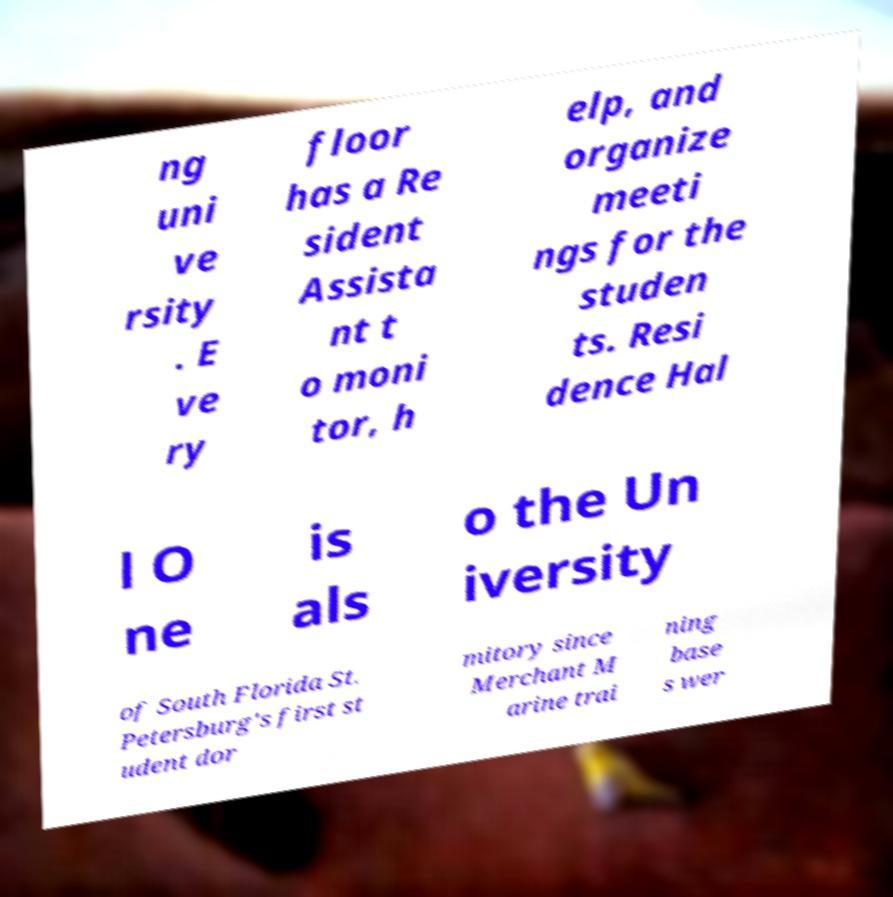Could you assist in decoding the text presented in this image and type it out clearly? ng uni ve rsity . E ve ry floor has a Re sident Assista nt t o moni tor, h elp, and organize meeti ngs for the studen ts. Resi dence Hal l O ne is als o the Un iversity of South Florida St. Petersburg's first st udent dor mitory since Merchant M arine trai ning base s wer 